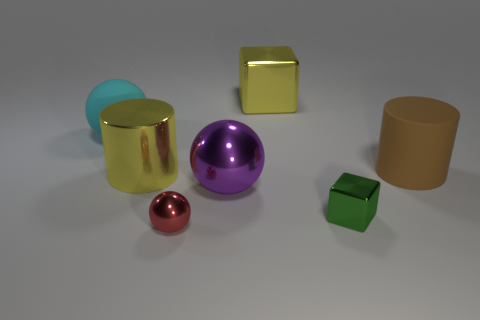What is the color of the big rubber thing that is left of the large yellow object that is on the left side of the metallic thing in front of the tiny green metal object?
Make the answer very short. Cyan. Is the number of rubber objects that are on the right side of the yellow cube less than the number of big brown rubber things?
Keep it short and to the point. No. Is the shape of the yellow metal object on the left side of the large cube the same as the small red object in front of the tiny block?
Your answer should be very brief. No. What number of things are either large yellow objects right of the small red metal thing or large matte cylinders?
Keep it short and to the point. 2. There is a object that is the same color as the metallic cylinder; what material is it?
Your answer should be compact. Metal. Are there any yellow cylinders that are on the left side of the big metallic thing left of the metal sphere in front of the tiny green metallic thing?
Provide a short and direct response. No. Is the number of big brown cylinders in front of the purple metallic sphere less than the number of red things that are on the left side of the big yellow cylinder?
Offer a terse response. No. What color is the cylinder that is made of the same material as the cyan object?
Offer a terse response. Brown. What is the color of the large sphere that is in front of the matte thing that is on the left side of the red sphere?
Offer a very short reply. Purple. Is there a cylinder that has the same color as the large block?
Give a very brief answer. Yes. 